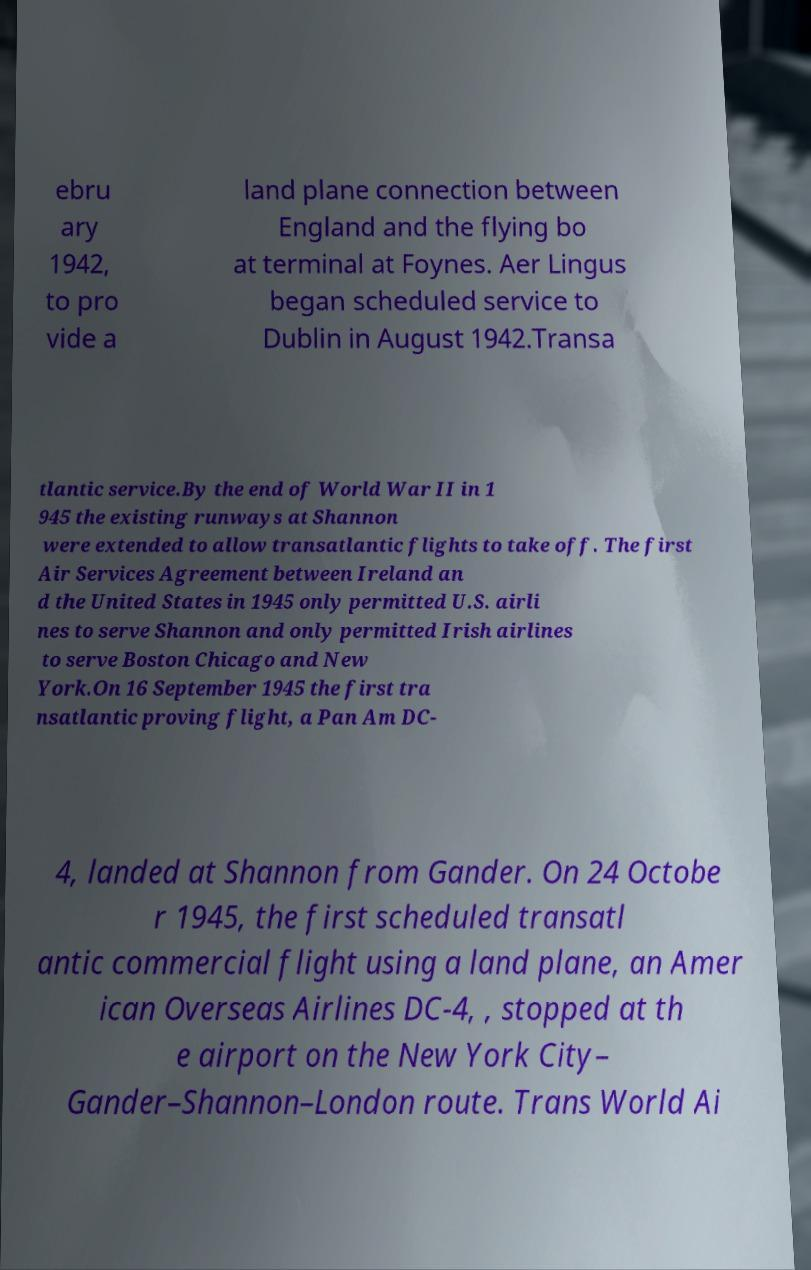Could you assist in decoding the text presented in this image and type it out clearly? ebru ary 1942, to pro vide a land plane connection between England and the flying bo at terminal at Foynes. Aer Lingus began scheduled service to Dublin in August 1942.Transa tlantic service.By the end of World War II in 1 945 the existing runways at Shannon were extended to allow transatlantic flights to take off. The first Air Services Agreement between Ireland an d the United States in 1945 only permitted U.S. airli nes to serve Shannon and only permitted Irish airlines to serve Boston Chicago and New York.On 16 September 1945 the first tra nsatlantic proving flight, a Pan Am DC- 4, landed at Shannon from Gander. On 24 Octobe r 1945, the first scheduled transatl antic commercial flight using a land plane, an Amer ican Overseas Airlines DC-4, , stopped at th e airport on the New York City– Gander–Shannon–London route. Trans World Ai 